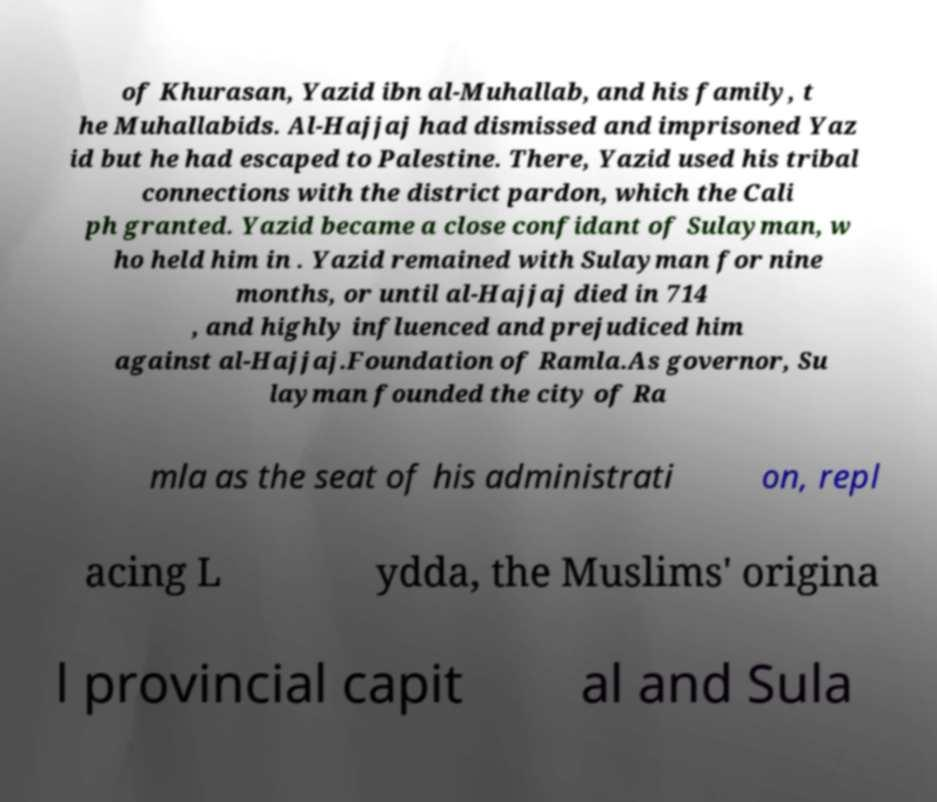For documentation purposes, I need the text within this image transcribed. Could you provide that? of Khurasan, Yazid ibn al-Muhallab, and his family, t he Muhallabids. Al-Hajjaj had dismissed and imprisoned Yaz id but he had escaped to Palestine. There, Yazid used his tribal connections with the district pardon, which the Cali ph granted. Yazid became a close confidant of Sulayman, w ho held him in . Yazid remained with Sulayman for nine months, or until al-Hajjaj died in 714 , and highly influenced and prejudiced him against al-Hajjaj.Foundation of Ramla.As governor, Su layman founded the city of Ra mla as the seat of his administrati on, repl acing L ydda, the Muslims' origina l provincial capit al and Sula 